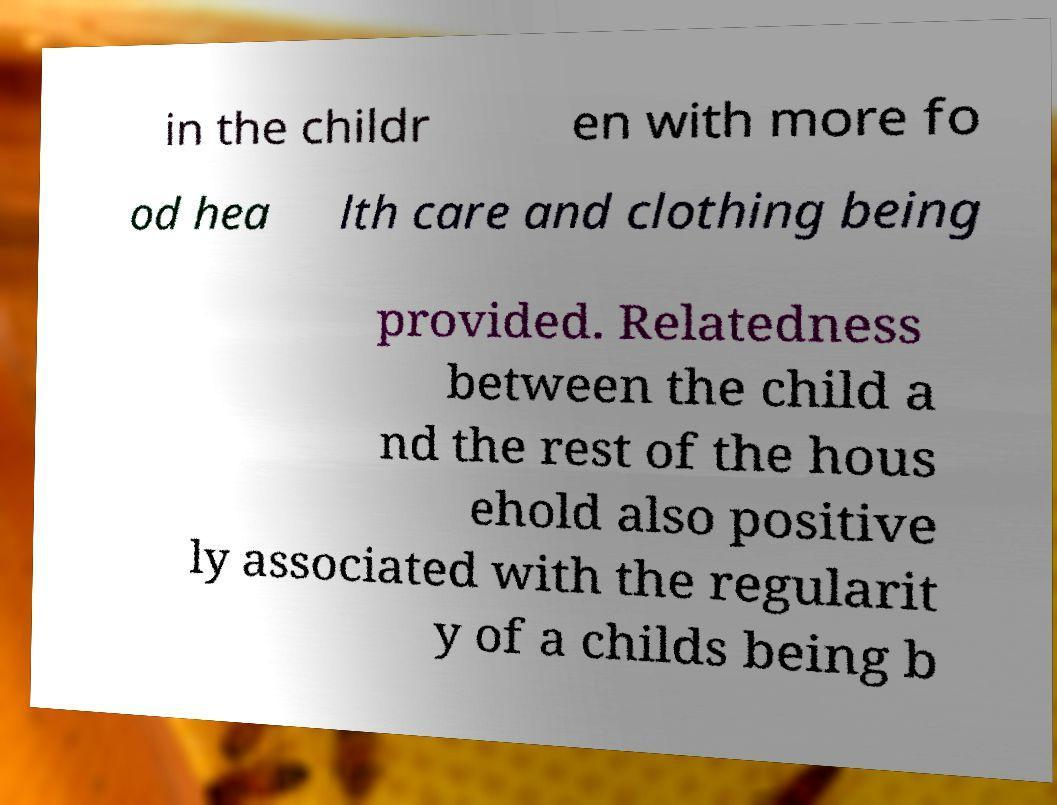Can you read and provide the text displayed in the image?This photo seems to have some interesting text. Can you extract and type it out for me? in the childr en with more fo od hea lth care and clothing being provided. Relatedness between the child a nd the rest of the hous ehold also positive ly associated with the regularit y of a childs being b 